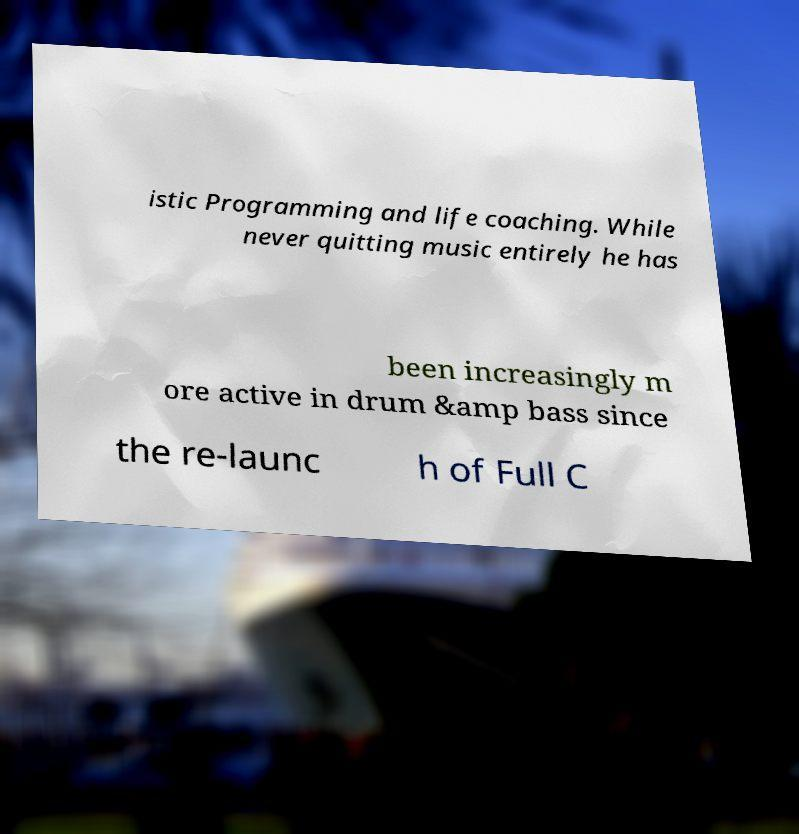Please read and relay the text visible in this image. What does it say? istic Programming and life coaching. While never quitting music entirely he has been increasingly m ore active in drum &amp bass since the re-launc h of Full C 